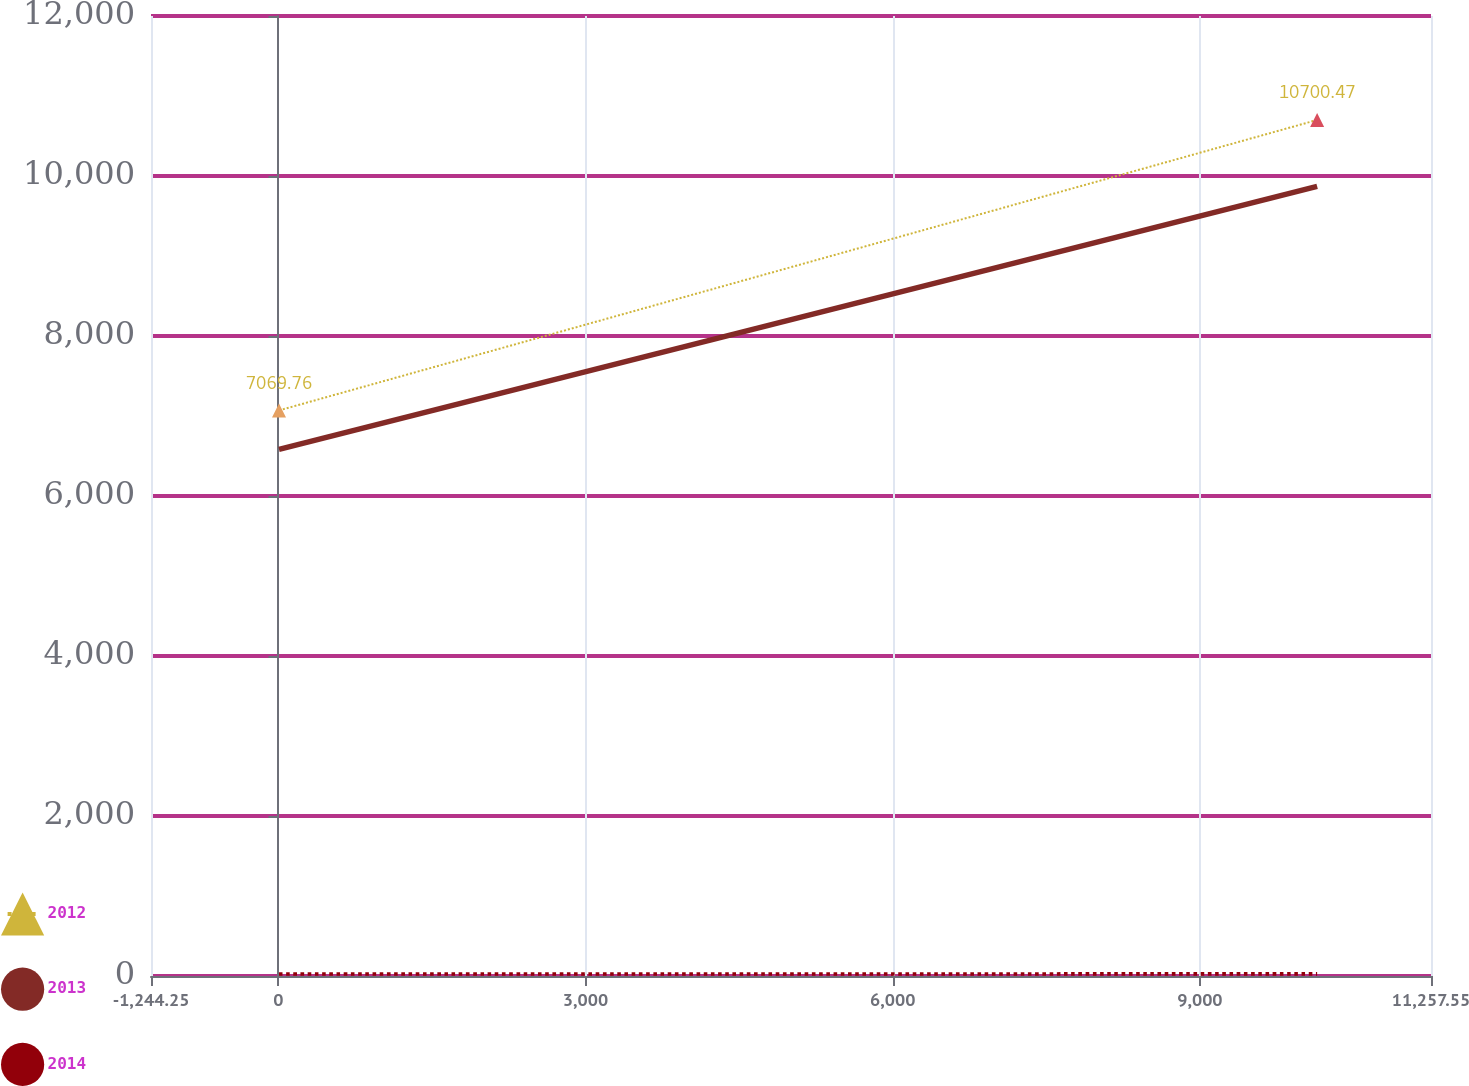Convert chart to OTSL. <chart><loc_0><loc_0><loc_500><loc_500><line_chart><ecel><fcel>2012<fcel>2013<fcel>2014<nl><fcel>5.93<fcel>7069.76<fcel>6583.34<fcel>24.09<nl><fcel>10145.4<fcel>10700.5<fcel>9869.47<fcel>26.55<nl><fcel>11326.6<fcel>9584.16<fcel>8968.5<fcel>20.22<nl><fcel>12507.7<fcel>0<fcel>0.06<fcel>0.01<nl></chart> 